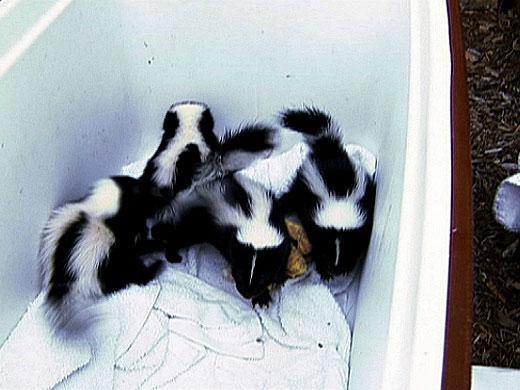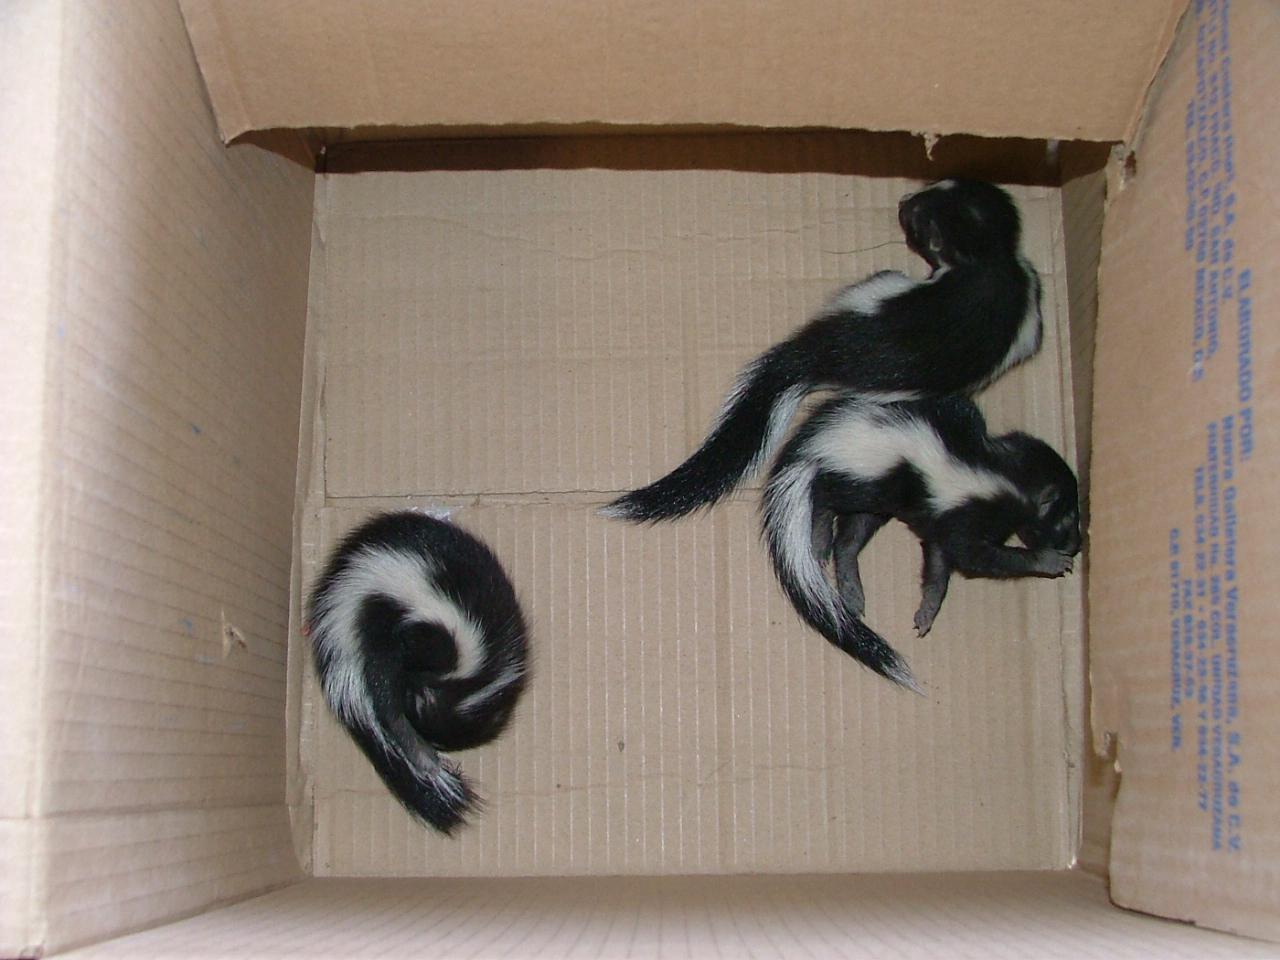The first image is the image on the left, the second image is the image on the right. Examine the images to the left and right. Is the description "All the skunks are in containers." accurate? Answer yes or no. Yes. The first image is the image on the left, the second image is the image on the right. Assess this claim about the two images: "Right and left images feature young skunks in containers, but only the container on the left has white bedding in it.". Correct or not? Answer yes or no. Yes. 